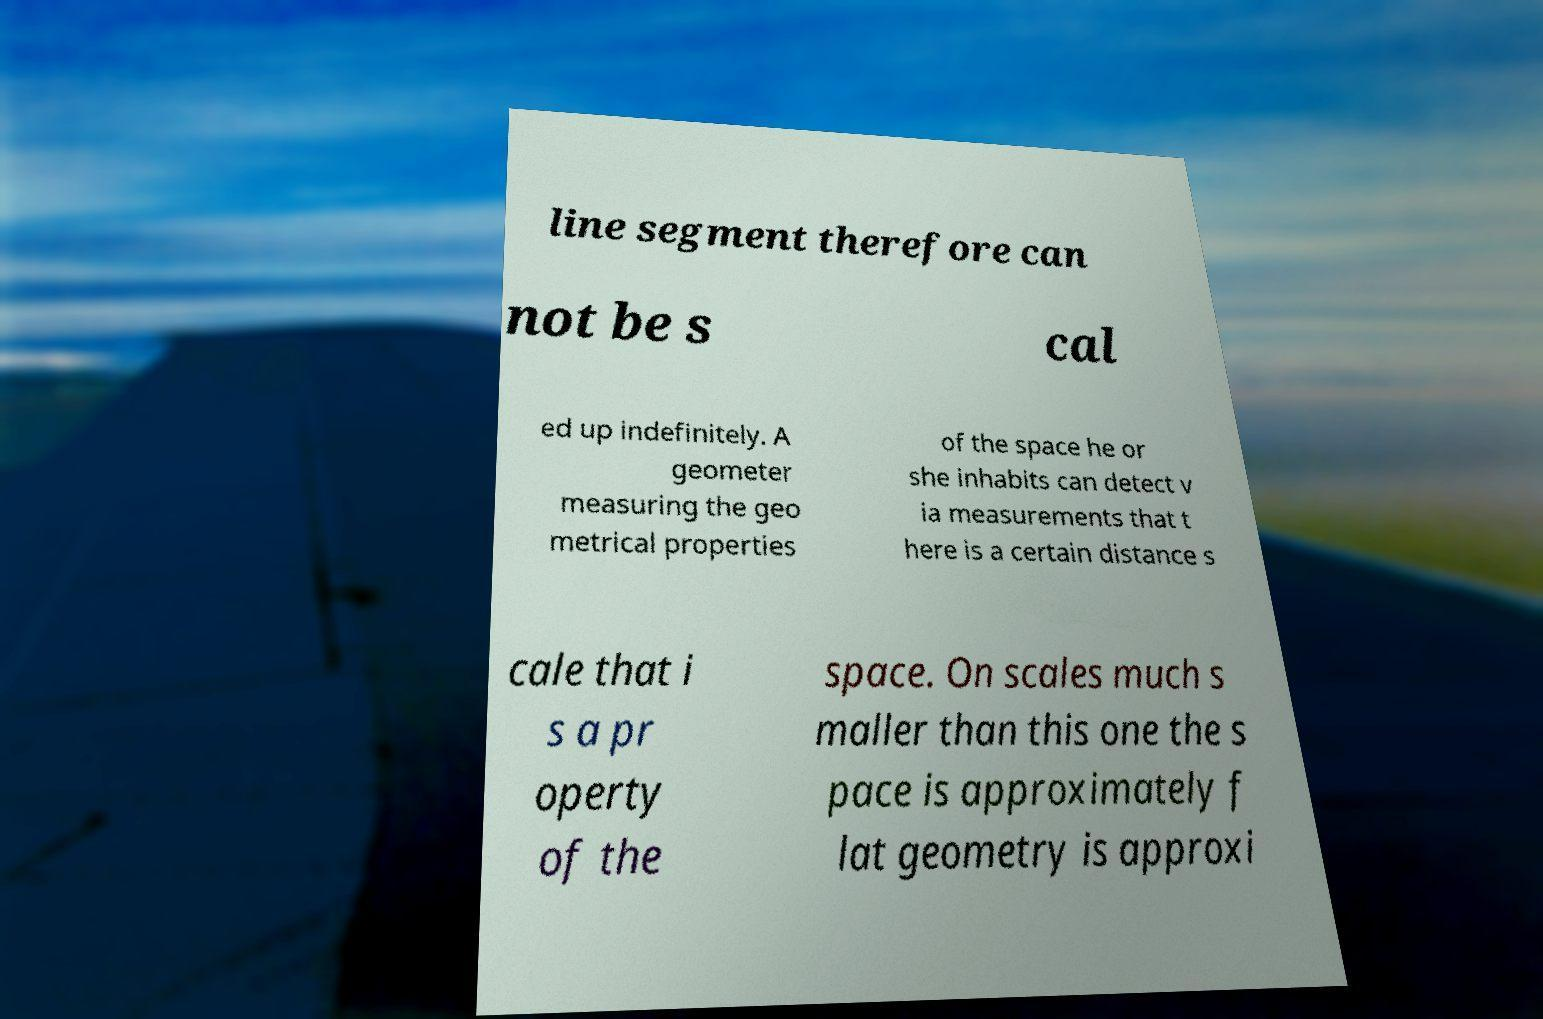Can you accurately transcribe the text from the provided image for me? line segment therefore can not be s cal ed up indefinitely. A geometer measuring the geo metrical properties of the space he or she inhabits can detect v ia measurements that t here is a certain distance s cale that i s a pr operty of the space. On scales much s maller than this one the s pace is approximately f lat geometry is approxi 